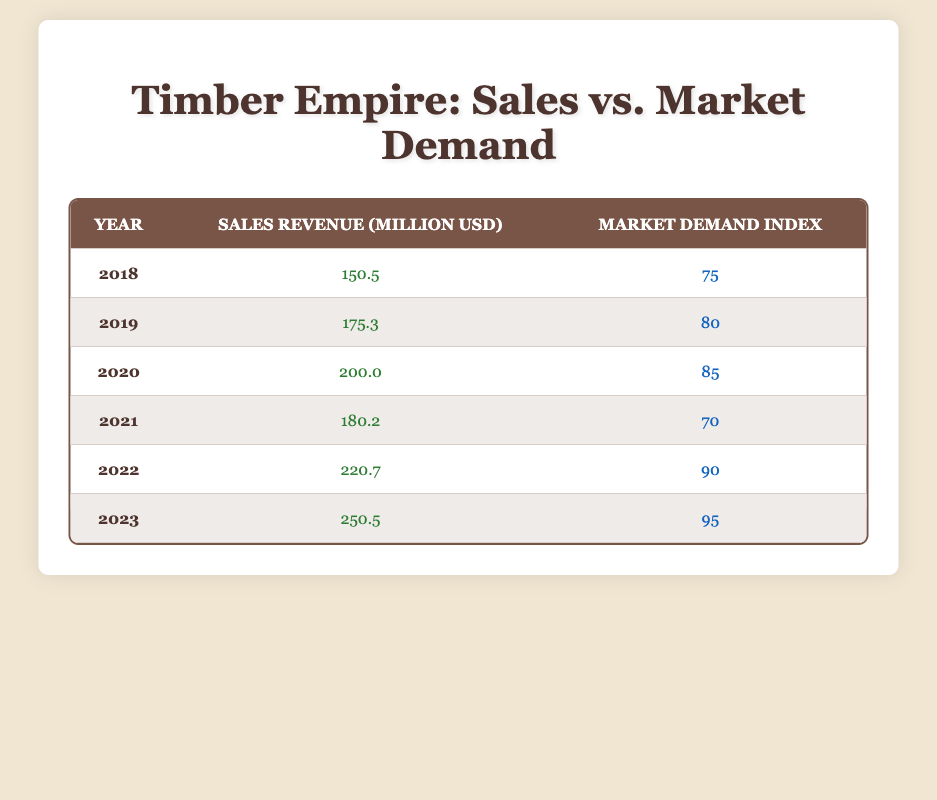What was the sales revenue in 2021? The table shows the year 2021 with a corresponding sales revenue listed as 180.2 million USD.
Answer: 180.2 million USD In which year did the sales revenue exceed 220 million USD? According to the table, the sales revenue first exceeds 220 million USD in the year 2022, which shows a sales revenue of 220.7 million USD.
Answer: 2022 What is the average market demand index over these years? To find the average, sum the market demand indices: (75 + 80 + 85 + 70 + 90 + 95) = 495. Then divide by the number of years (6): 495 / 6 = 82.5.
Answer: 82.5 Is the market demand index higher in 2023 than in 2019? By comparing the values in the table, the market demand index in 2023 is 95, while in 2019 it is 80. Since 95 is greater than 80, the statement is true.
Answer: Yes What is the difference in sales revenue between 2023 and 2018? The sales revenue for 2023 is 250.5 million USD and for 2018 is 150.5 million USD. The difference is 250.5 - 150.5 = 100 million USD.
Answer: 100 million USD Which year had the highest market demand index? Looking at the table, the year with the highest market demand index is 2023, with a demand index of 95.
Answer: 2023 How many years had a sales revenue below 200 million USD? The years with sales revenue below 200 million USD are 2018 (150.5), 2019 (175.3), 2020 (200.0), and 2021 (180.2), which makes a total of 4 years.
Answer: 4 years Did the sales revenue increase from 2020 to 2021? The sales revenue in 2020 is 200 million USD and in 2021 it is 180.2 million USD. Since 180.2 is less than 200, the answer is no.
Answer: No In how many years did the market demand index rise compared to the previous year? Reviewing the data: 2019 to 2020, 2021 to 2022, and 2022 to 2023 show an increase. Specifically, 2018 to 2019 (increased), 2019 to 2020 (increased), 2021 to 2022 (increased), 2022 to 2023 (increased); 4 instances show an increase out of 5 comparisons.
Answer: 4 times 